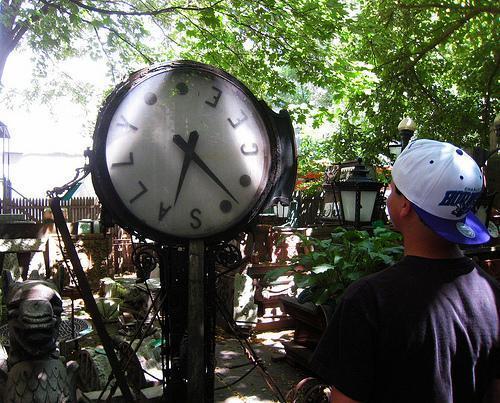How many clocks are there?
Give a very brief answer. 1. 